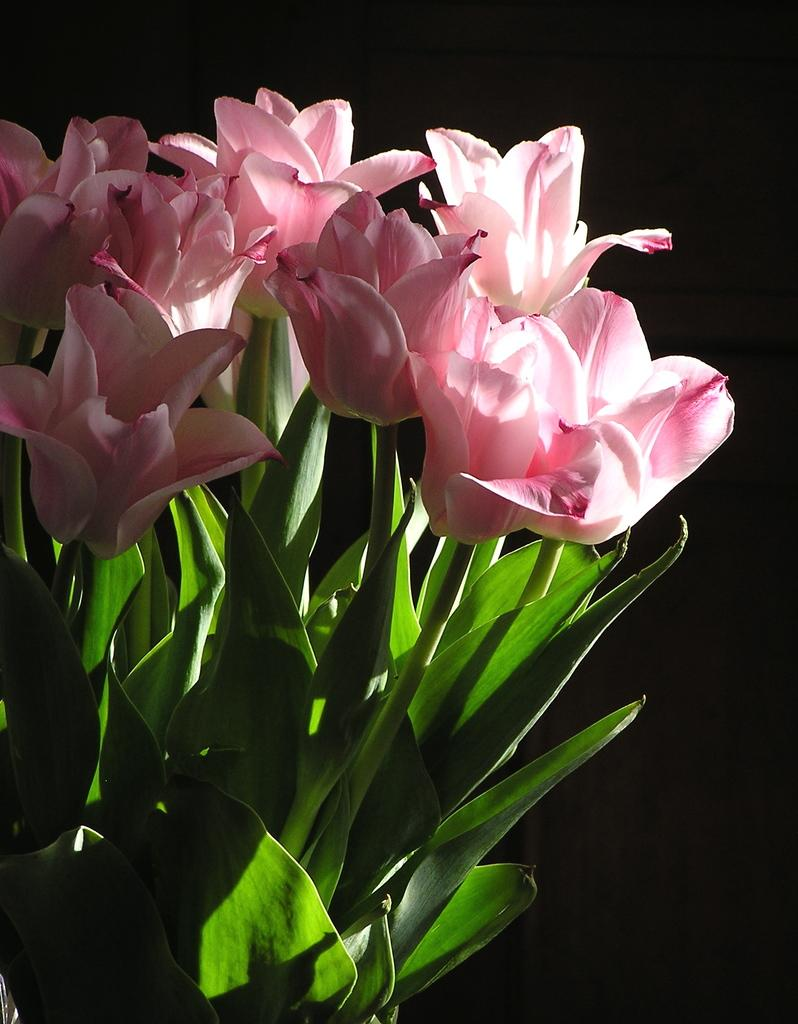What is the main subject in the center of the image? There is a plant with flowers in the center of the image. What can be observed about the background of the image? The background of the image is dark. What flavor of ice cream is being served in the picture? There is no picture or ice cream present in the image; it features a plant with flowers. What territory is depicted in the image? The image does not depict any specific territory; it features a plant with flowers. 